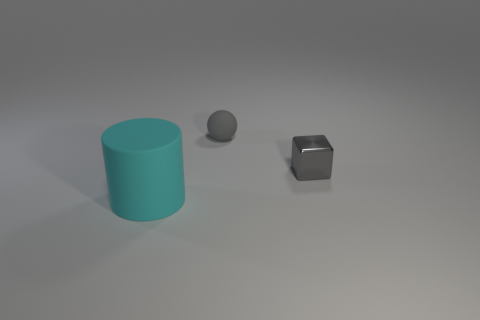Add 1 big brown metal cylinders. How many objects exist? 4 Subtract all blocks. How many objects are left? 2 Add 3 gray spheres. How many gray spheres are left? 4 Add 1 tiny yellow blocks. How many tiny yellow blocks exist? 1 Subtract 0 red spheres. How many objects are left? 3 Subtract all large brown matte balls. Subtract all matte balls. How many objects are left? 2 